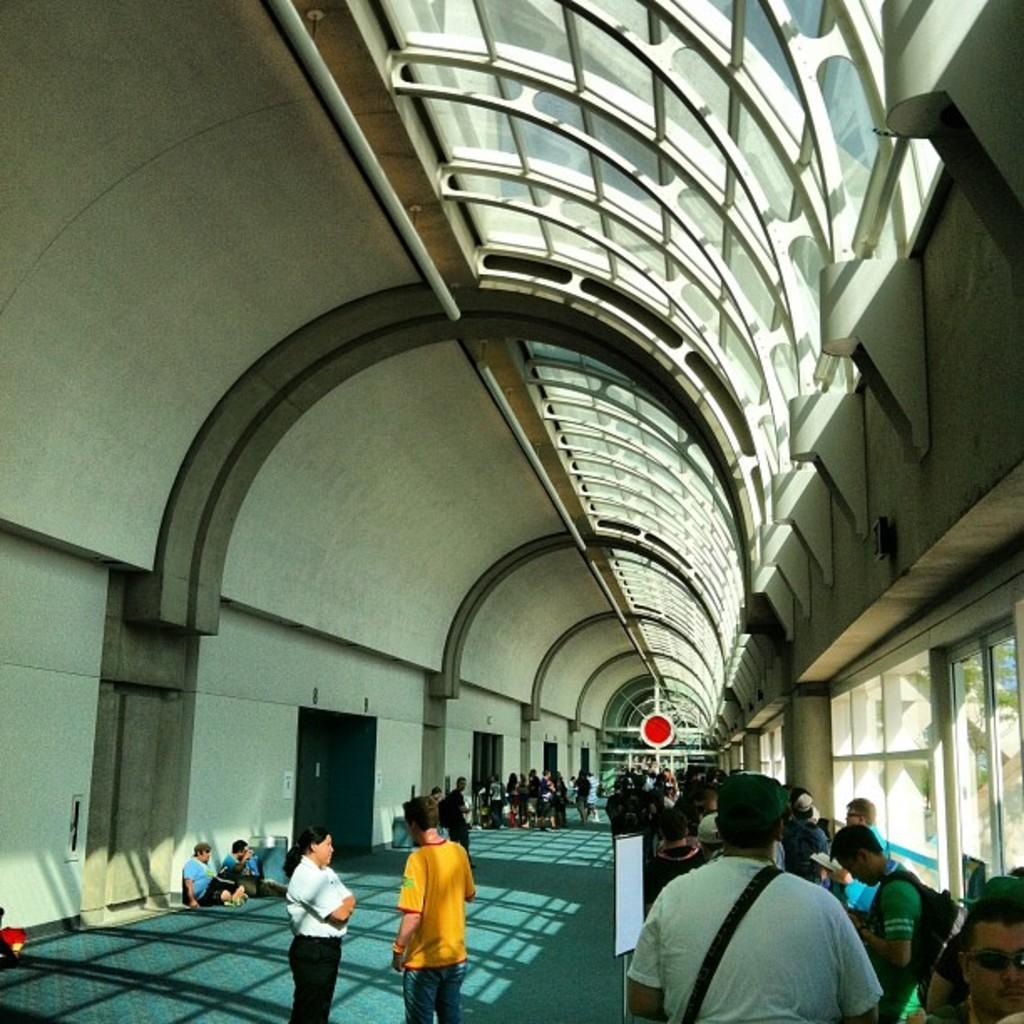Could you give a brief overview of what you see in this image? On the right side, there are persons standing. On the left side, there are two persons standing. In the background, there are other persons. Top of these persons, there is a roof. 